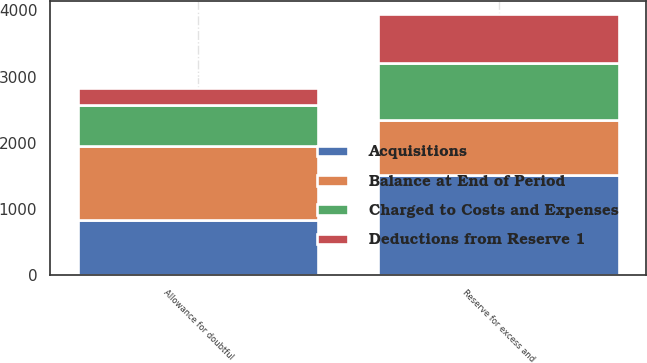<chart> <loc_0><loc_0><loc_500><loc_500><stacked_bar_chart><ecel><fcel>Allowance for doubtful<fcel>Reserve for excess and<nl><fcel>Balance at End of Period<fcel>1110<fcel>834<nl><fcel>Charged to Costs and Expenses<fcel>627<fcel>865<nl><fcel>Deductions from Reserve 1<fcel>257<fcel>728<nl><fcel>Acquisitions<fcel>834<fcel>1512<nl></chart> 